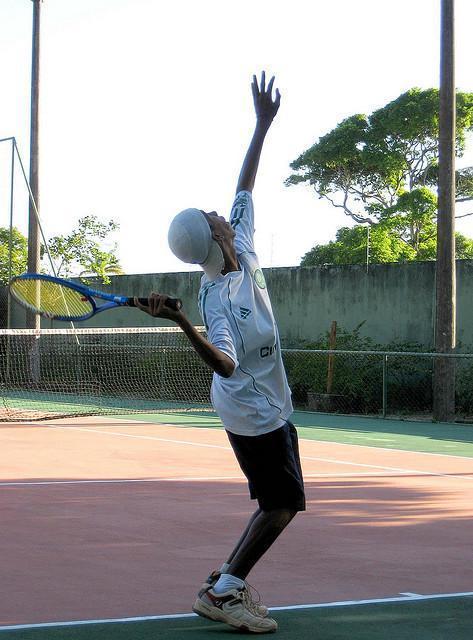How many tennis rackets are there?
Give a very brief answer. 1. 